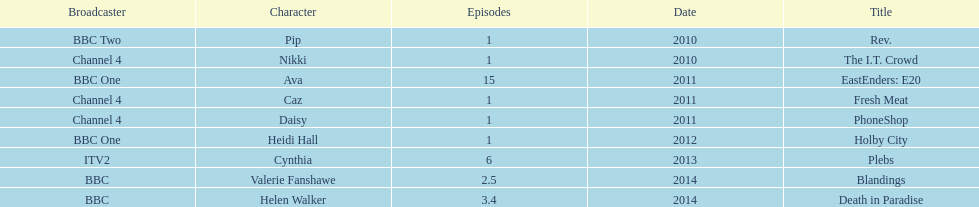What is the only role she played with broadcaster itv2? Cynthia. 